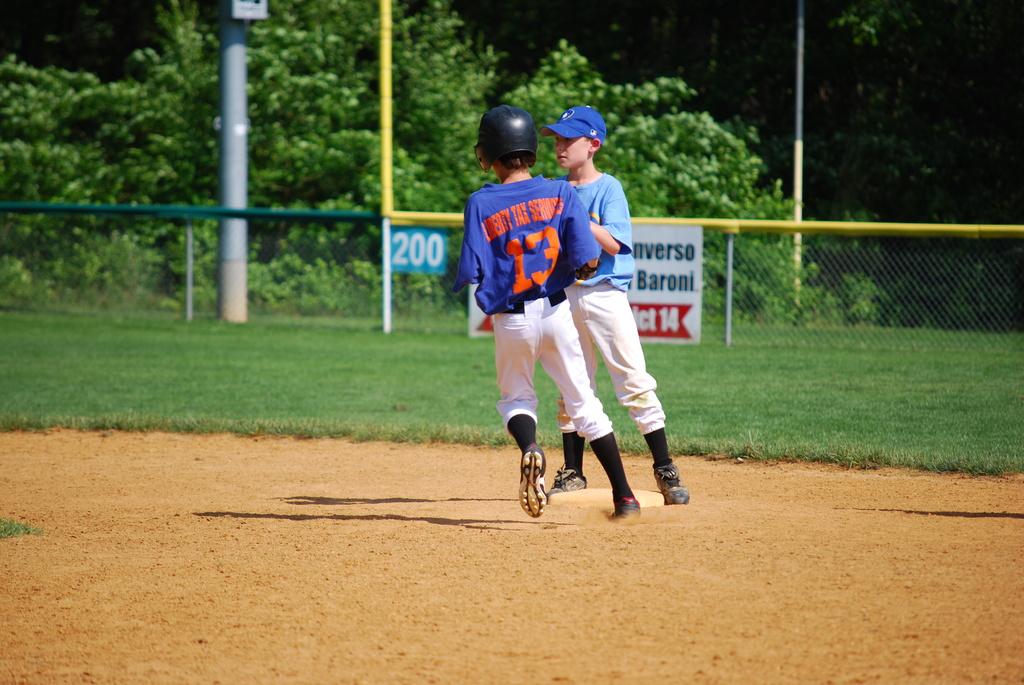How far is the outfield fence?
Keep it short and to the point. 200. 